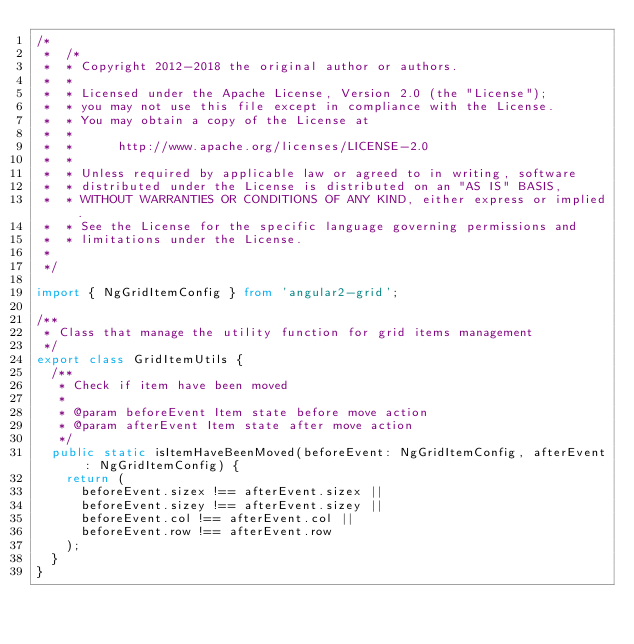<code> <loc_0><loc_0><loc_500><loc_500><_TypeScript_>/*
 *  /*
 *  * Copyright 2012-2018 the original author or authors.
 *  *
 *  * Licensed under the Apache License, Version 2.0 (the "License");
 *  * you may not use this file except in compliance with the License.
 *  * You may obtain a copy of the License at
 *  *
 *  *      http://www.apache.org/licenses/LICENSE-2.0
 *  *
 *  * Unless required by applicable law or agreed to in writing, software
 *  * distributed under the License is distributed on an "AS IS" BASIS,
 *  * WITHOUT WARRANTIES OR CONDITIONS OF ANY KIND, either express or implied.
 *  * See the License for the specific language governing permissions and
 *  * limitations under the License.
 *
 */

import { NgGridItemConfig } from 'angular2-grid';

/**
 * Class that manage the utility function for grid items management
 */
export class GridItemUtils {
  /**
   * Check if item have been moved
   *
   * @param beforeEvent Item state before move action
   * @param afterEvent Item state after move action
   */
  public static isItemHaveBeenMoved(beforeEvent: NgGridItemConfig, afterEvent: NgGridItemConfig) {
    return (
      beforeEvent.sizex !== afterEvent.sizex ||
      beforeEvent.sizey !== afterEvent.sizey ||
      beforeEvent.col !== afterEvent.col ||
      beforeEvent.row !== afterEvent.row
    );
  }
}
</code> 